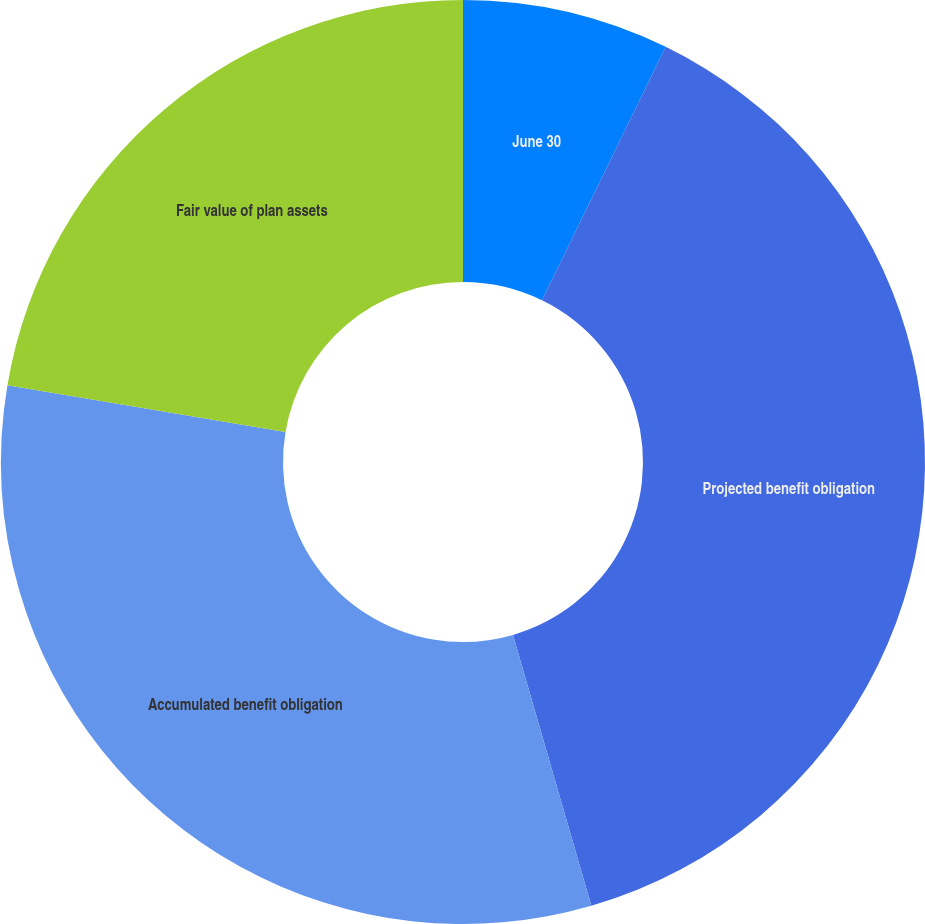<chart> <loc_0><loc_0><loc_500><loc_500><pie_chart><fcel>June 30<fcel>Projected benefit obligation<fcel>Accumulated benefit obligation<fcel>Fair value of plan assets<nl><fcel>7.23%<fcel>38.29%<fcel>32.14%<fcel>22.34%<nl></chart> 